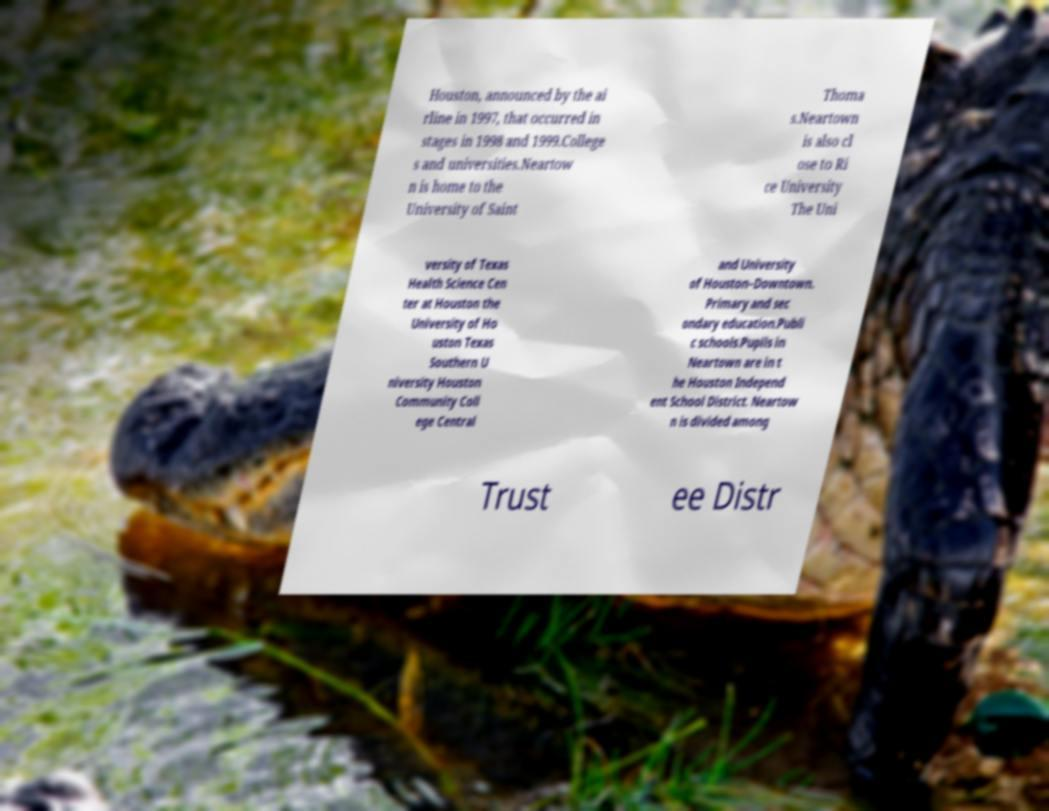Please read and relay the text visible in this image. What does it say? Houston, announced by the ai rline in 1997, that occurred in stages in 1998 and 1999.College s and universities.Neartow n is home to the University of Saint Thoma s.Neartown is also cl ose to Ri ce University The Uni versity of Texas Health Science Cen ter at Houston the University of Ho uston Texas Southern U niversity Houston Community Coll ege Central and University of Houston–Downtown. Primary and sec ondary education.Publi c schools.Pupils in Neartown are in t he Houston Independ ent School District. Neartow n is divided among Trust ee Distr 